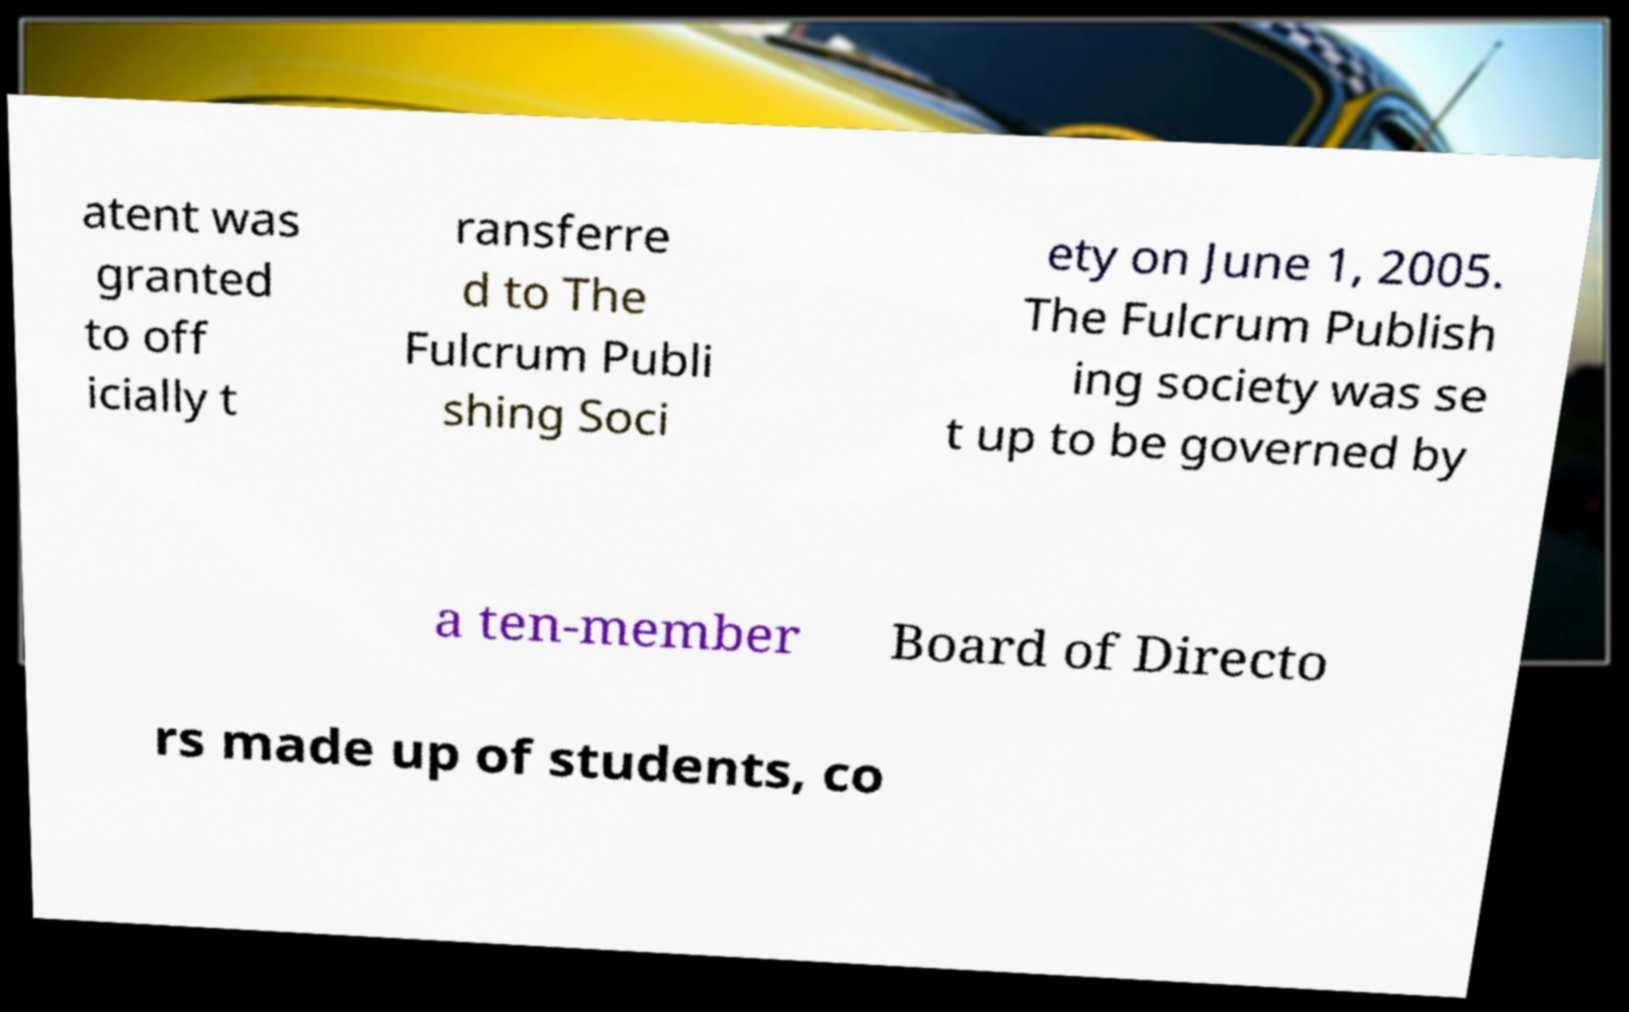Could you assist in decoding the text presented in this image and type it out clearly? atent was granted to off icially t ransferre d to The Fulcrum Publi shing Soci ety on June 1, 2005. The Fulcrum Publish ing society was se t up to be governed by a ten-member Board of Directo rs made up of students, co 